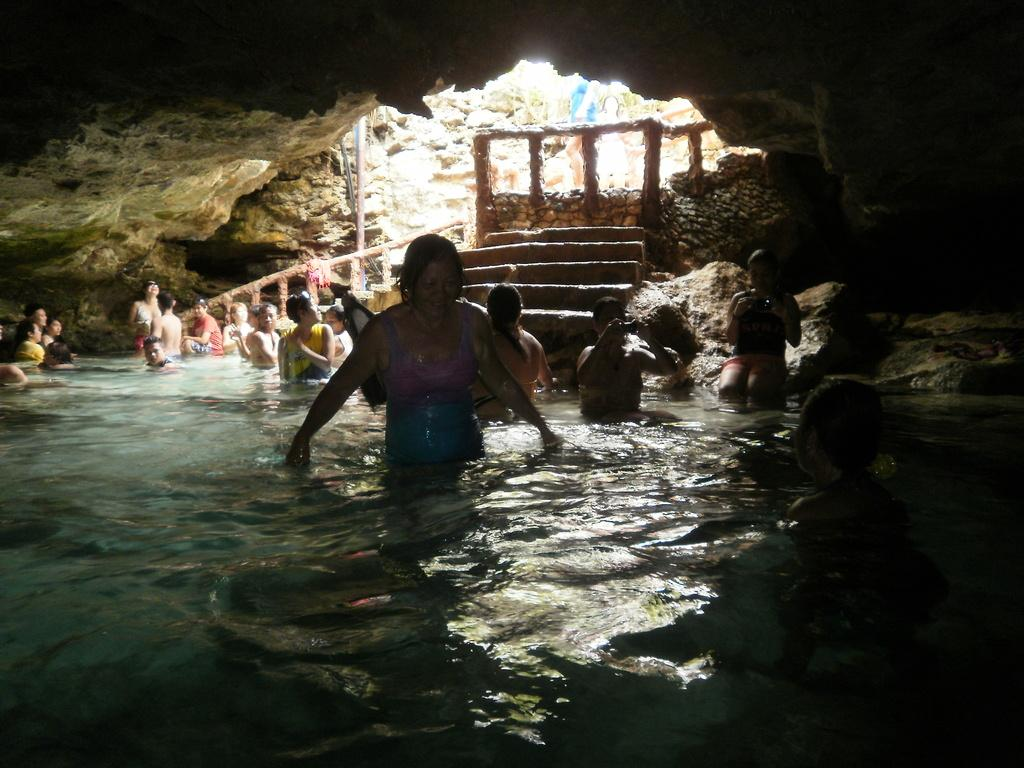What are the people in the image doing? The people in the image are standing in the water. What can be found inside the cave? There are rocks in a cave. What architectural feature is visible in the image? There are steps visible in the image. What type of structure is in the background? There is a stone wall in the background. What is the reason for the people's journey in the image? There is no information about a journey or reason for the people's presence in the image. What type of expansion can be seen in the image? There is no expansion visible in the image; it features people standing in water, rocks in a cave, steps, and a stone wall. 